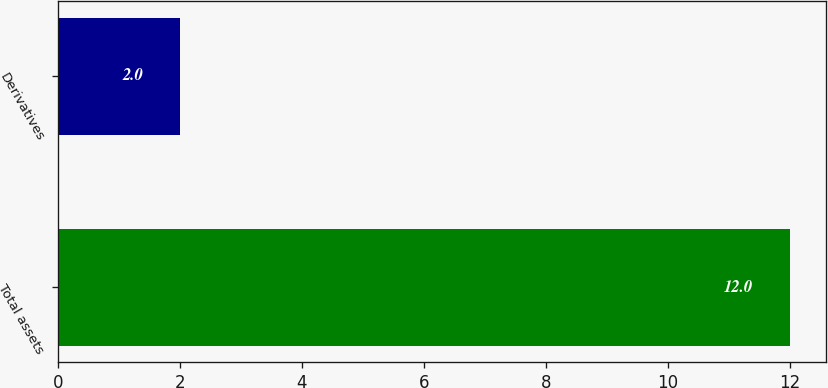Convert chart to OTSL. <chart><loc_0><loc_0><loc_500><loc_500><bar_chart><fcel>Total assets<fcel>Derivatives<nl><fcel>12<fcel>2<nl></chart> 